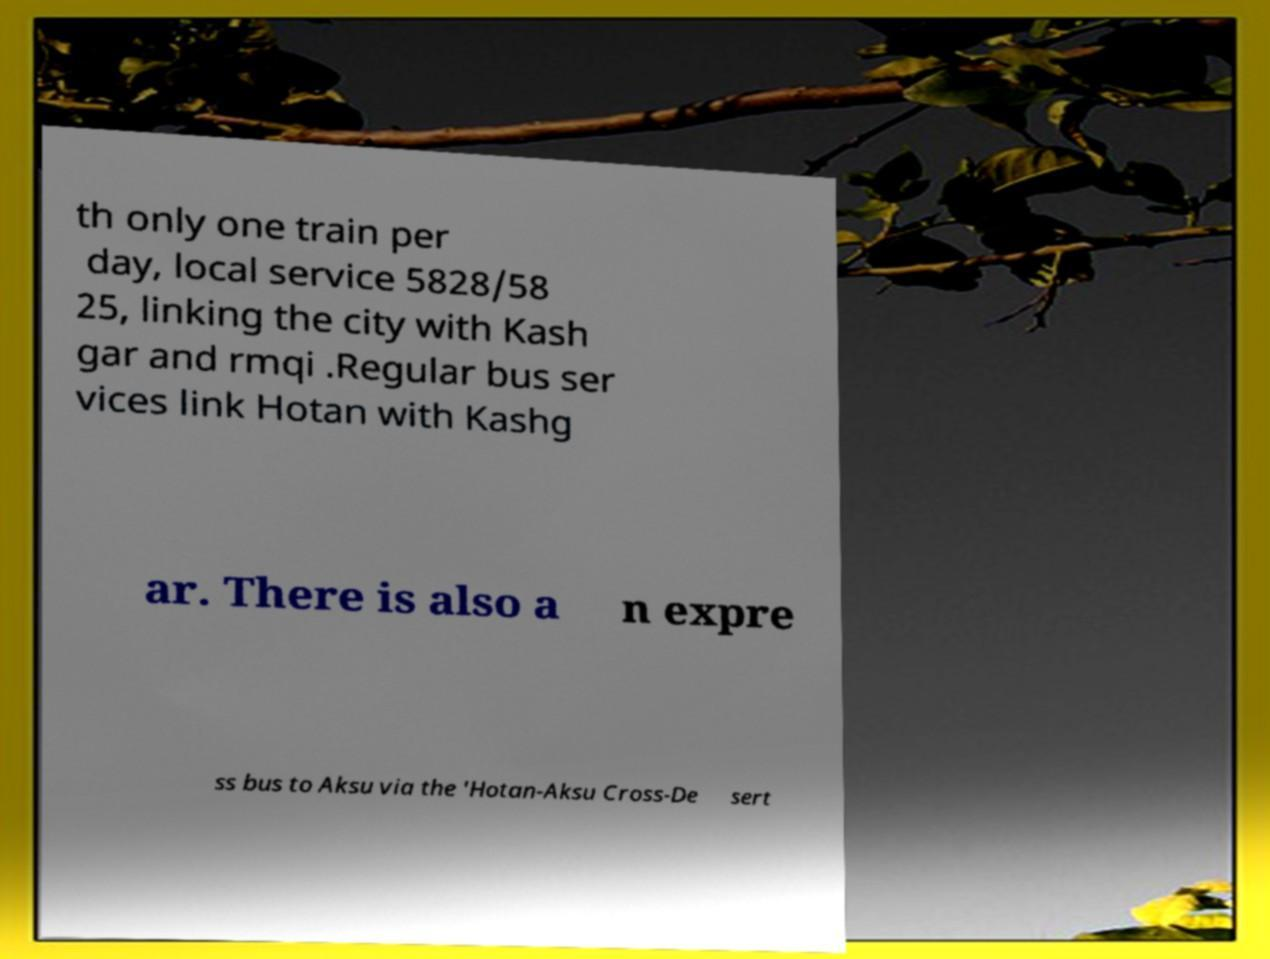Please read and relay the text visible in this image. What does it say? th only one train per day, local service 5828/58 25, linking the city with Kash gar and rmqi .Regular bus ser vices link Hotan with Kashg ar. There is also a n expre ss bus to Aksu via the 'Hotan-Aksu Cross-De sert 